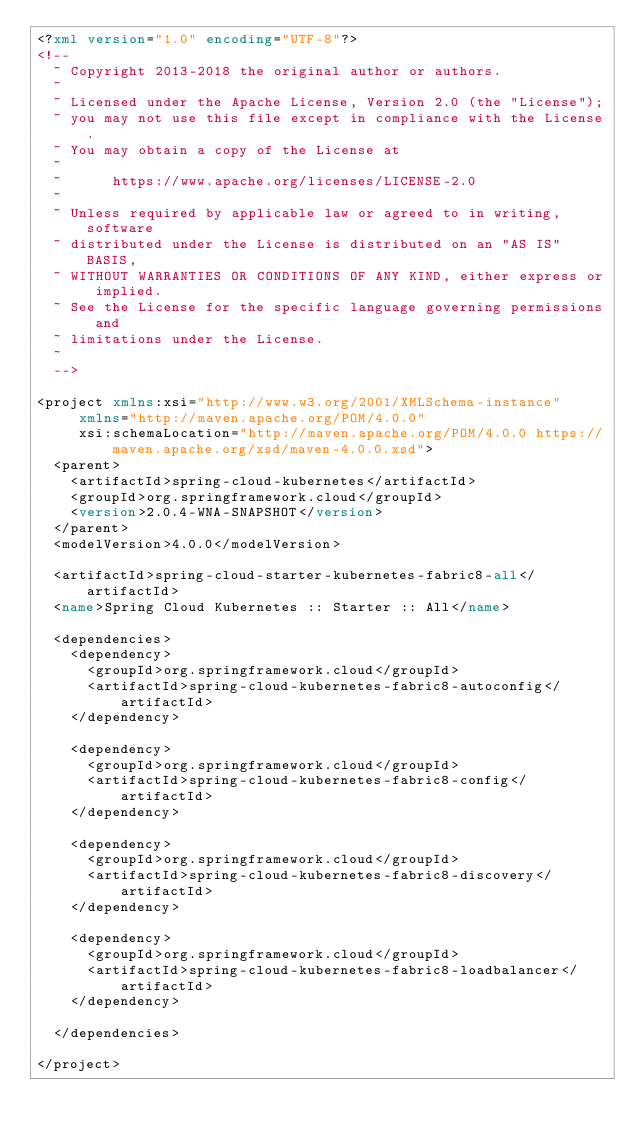Convert code to text. <code><loc_0><loc_0><loc_500><loc_500><_XML_><?xml version="1.0" encoding="UTF-8"?>
<!--
  ~ Copyright 2013-2018 the original author or authors.
  ~
  ~ Licensed under the Apache License, Version 2.0 (the "License");
  ~ you may not use this file except in compliance with the License.
  ~ You may obtain a copy of the License at
  ~
  ~      https://www.apache.org/licenses/LICENSE-2.0
  ~
  ~ Unless required by applicable law or agreed to in writing, software
  ~ distributed under the License is distributed on an "AS IS" BASIS,
  ~ WITHOUT WARRANTIES OR CONDITIONS OF ANY KIND, either express or implied.
  ~ See the License for the specific language governing permissions and
  ~ limitations under the License.
  ~
  -->

<project xmlns:xsi="http://www.w3.org/2001/XMLSchema-instance"
		 xmlns="http://maven.apache.org/POM/4.0.0"
		 xsi:schemaLocation="http://maven.apache.org/POM/4.0.0 https://maven.apache.org/xsd/maven-4.0.0.xsd">
	<parent>
		<artifactId>spring-cloud-kubernetes</artifactId>
		<groupId>org.springframework.cloud</groupId>
		<version>2.0.4-WNA-SNAPSHOT</version>
	</parent>
	<modelVersion>4.0.0</modelVersion>

	<artifactId>spring-cloud-starter-kubernetes-fabric8-all</artifactId>
	<name>Spring Cloud Kubernetes :: Starter :: All</name>

	<dependencies>
		<dependency>
			<groupId>org.springframework.cloud</groupId>
			<artifactId>spring-cloud-kubernetes-fabric8-autoconfig</artifactId>
		</dependency>

		<dependency>
			<groupId>org.springframework.cloud</groupId>
			<artifactId>spring-cloud-kubernetes-fabric8-config</artifactId>
		</dependency>

		<dependency>
			<groupId>org.springframework.cloud</groupId>
			<artifactId>spring-cloud-kubernetes-fabric8-discovery</artifactId>
		</dependency>

		<dependency>
			<groupId>org.springframework.cloud</groupId>
			<artifactId>spring-cloud-kubernetes-fabric8-loadbalancer</artifactId>
		</dependency>

	</dependencies>

</project>
</code> 